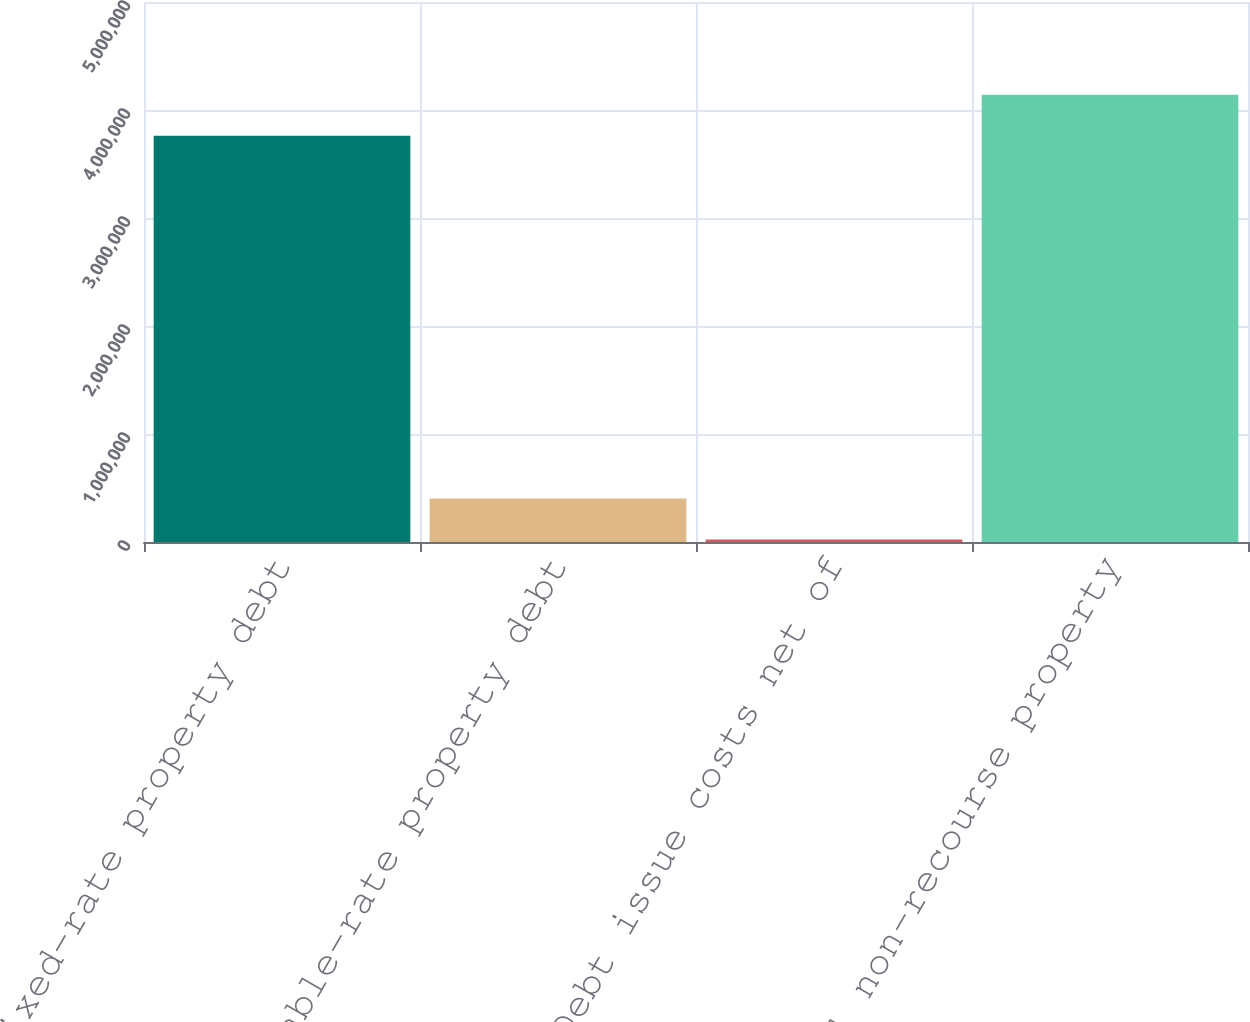<chart> <loc_0><loc_0><loc_500><loc_500><bar_chart><fcel>Fixed-rate property debt<fcel>Variable-rate property debt<fcel>Debt issue costs net of<fcel>Total non-recourse property<nl><fcel>3.76124e+06<fcel>403831<fcel>24019<fcel>4.14105e+06<nl></chart> 